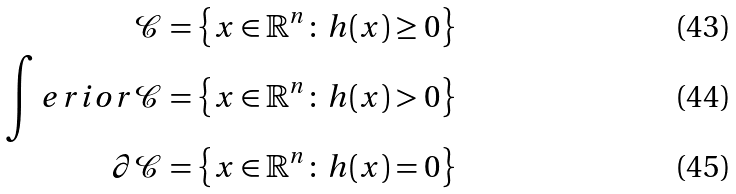Convert formula to latex. <formula><loc_0><loc_0><loc_500><loc_500>\mathcal { C } & = \left \{ x \in \mathbb { R } ^ { n } \colon \, h ( x ) \geq 0 \right \} \\ \int e r i o r { \mathcal { C } } & = \left \{ x \in \mathbb { R } ^ { n } \colon \, h ( x ) > 0 \right \} \\ \partial \mathcal { C } & = \left \{ x \in \mathbb { R } ^ { n } \colon \, h ( x ) = 0 \right \}</formula> 